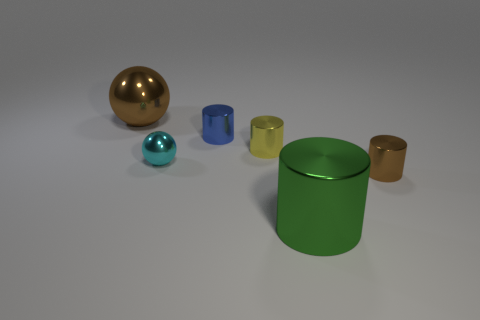Is there any other thing that is the same color as the big metal sphere?
Your response must be concise. Yes. There is a big shiny thing behind the green cylinder; is it the same color as the small cylinder that is in front of the yellow metallic cylinder?
Your response must be concise. Yes. Are there more cylinders behind the tiny cyan object than cyan things?
Provide a short and direct response. Yes. What color is the shiny ball right of the big sphere?
Offer a very short reply. Cyan. What number of metallic objects are either balls or brown balls?
Offer a very short reply. 2. Is there a big metal thing that is on the right side of the tiny cyan metallic ball that is behind the brown metallic object on the right side of the blue metal cylinder?
Keep it short and to the point. Yes. How many brown objects are in front of the brown sphere?
Provide a succinct answer. 1. There is a tiny object that is the same color as the large ball; what is its material?
Provide a succinct answer. Metal. What number of tiny objects are either gray metal cylinders or brown balls?
Your response must be concise. 0. What shape is the brown metal thing that is on the left side of the green shiny thing?
Provide a short and direct response. Sphere. 